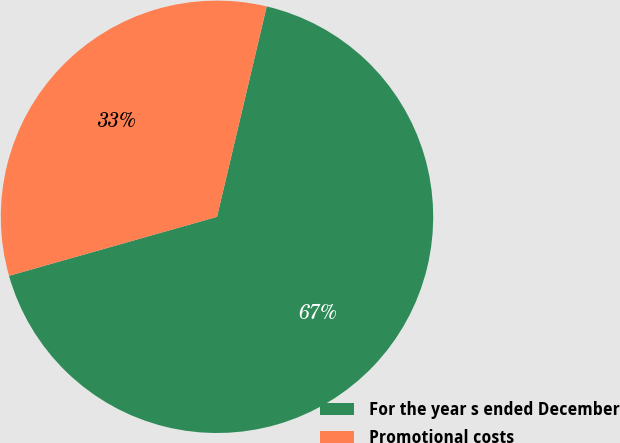Convert chart. <chart><loc_0><loc_0><loc_500><loc_500><pie_chart><fcel>For the year s ended December<fcel>Promotional costs<nl><fcel>66.91%<fcel>33.09%<nl></chart> 